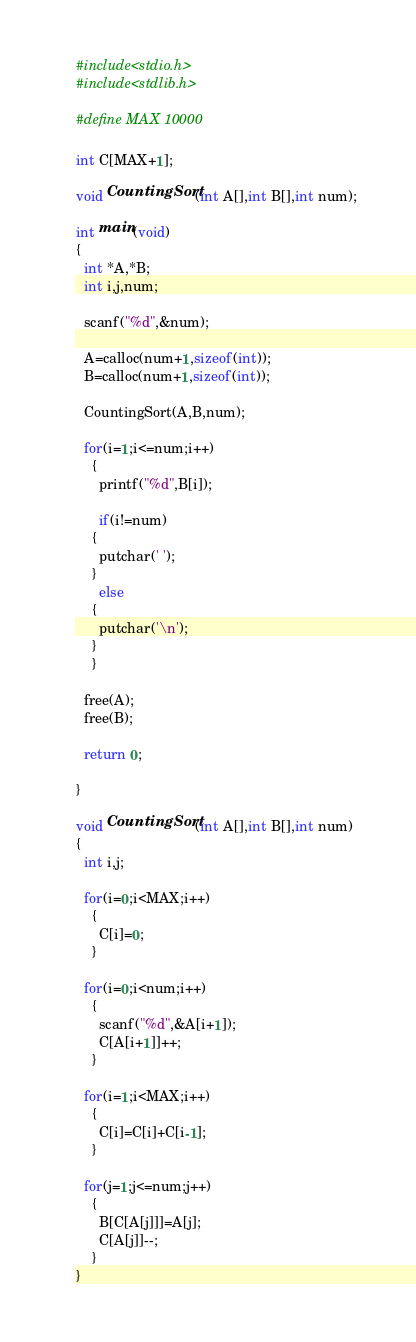Convert code to text. <code><loc_0><loc_0><loc_500><loc_500><_C_>#include<stdio.h>
#include<stdlib.h>

#define MAX 10000

int C[MAX+1];

void CountingSort(int A[],int B[],int num);

int main(void)
{
  int *A,*B;
  int i,j,num;

  scanf("%d",&num);

  A=calloc(num+1,sizeof(int));
  B=calloc(num+1,sizeof(int));

  CountingSort(A,B,num);

  for(i=1;i<=num;i++)
    {
      printf("%d",B[i]);

      if(i!=num)
	{
	  putchar(' ');
	}
      else
	{
	  putchar('\n');
	}
    }

  free(A);
  free(B);
  
  return 0;

}

void CountingSort(int A[],int B[],int num)
{
  int i,j;
  
  for(i=0;i<MAX;i++)
    {
      C[i]=0;
    }

  for(i=0;i<num;i++)
    {
      scanf("%d",&A[i+1]);
      C[A[i+1]]++;
    }

  for(i=1;i<MAX;i++)
    {
      C[i]=C[i]+C[i-1];
    }

  for(j=1;j<=num;j++)
    {
      B[C[A[j]]]=A[j];
      C[A[j]]--;
    }
}

</code> 